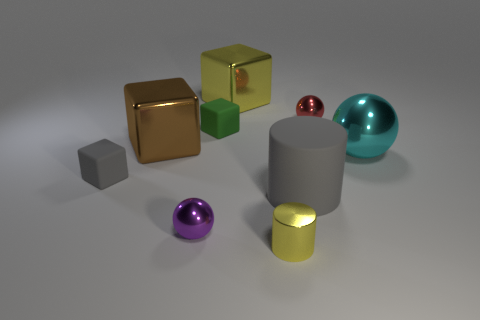Are there fewer large rubber balls than cyan metallic objects?
Your answer should be compact. Yes. Does the small red shiny object have the same shape as the yellow metallic object that is behind the purple metal thing?
Your answer should be compact. No. What is the shape of the tiny object that is on the right side of the purple object and in front of the large gray cylinder?
Your answer should be very brief. Cylinder. Are there an equal number of small green cubes that are on the right side of the large yellow block and cubes that are right of the purple shiny ball?
Keep it short and to the point. No. Does the yellow shiny object that is behind the yellow cylinder have the same shape as the tiny purple shiny object?
Offer a very short reply. No. What number of gray things are metal cylinders or big metallic things?
Keep it short and to the point. 0. There is a small gray object that is the same shape as the big brown object; what is its material?
Give a very brief answer. Rubber. There is a gray thing in front of the small gray rubber object; what shape is it?
Ensure brevity in your answer.  Cylinder. Is there a tiny red object made of the same material as the yellow block?
Your answer should be compact. Yes. Is the brown shiny cube the same size as the purple sphere?
Offer a terse response. No. 